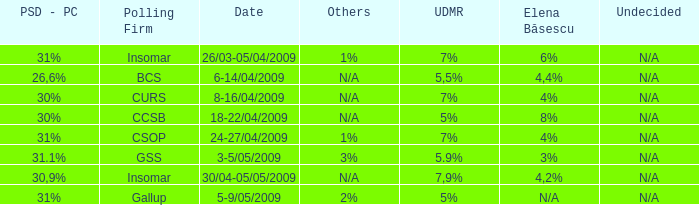What was the polling firm with others of 1%? Insomar, CSOP. 